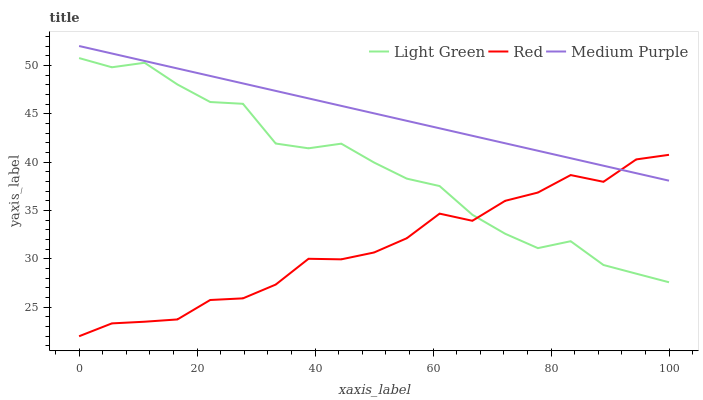Does Red have the minimum area under the curve?
Answer yes or no. Yes. Does Medium Purple have the maximum area under the curve?
Answer yes or no. Yes. Does Light Green have the minimum area under the curve?
Answer yes or no. No. Does Light Green have the maximum area under the curve?
Answer yes or no. No. Is Medium Purple the smoothest?
Answer yes or no. Yes. Is Light Green the roughest?
Answer yes or no. Yes. Is Red the smoothest?
Answer yes or no. No. Is Red the roughest?
Answer yes or no. No. Does Red have the lowest value?
Answer yes or no. Yes. Does Light Green have the lowest value?
Answer yes or no. No. Does Medium Purple have the highest value?
Answer yes or no. Yes. Does Light Green have the highest value?
Answer yes or no. No. Is Light Green less than Medium Purple?
Answer yes or no. Yes. Is Medium Purple greater than Light Green?
Answer yes or no. Yes. Does Medium Purple intersect Red?
Answer yes or no. Yes. Is Medium Purple less than Red?
Answer yes or no. No. Is Medium Purple greater than Red?
Answer yes or no. No. Does Light Green intersect Medium Purple?
Answer yes or no. No. 